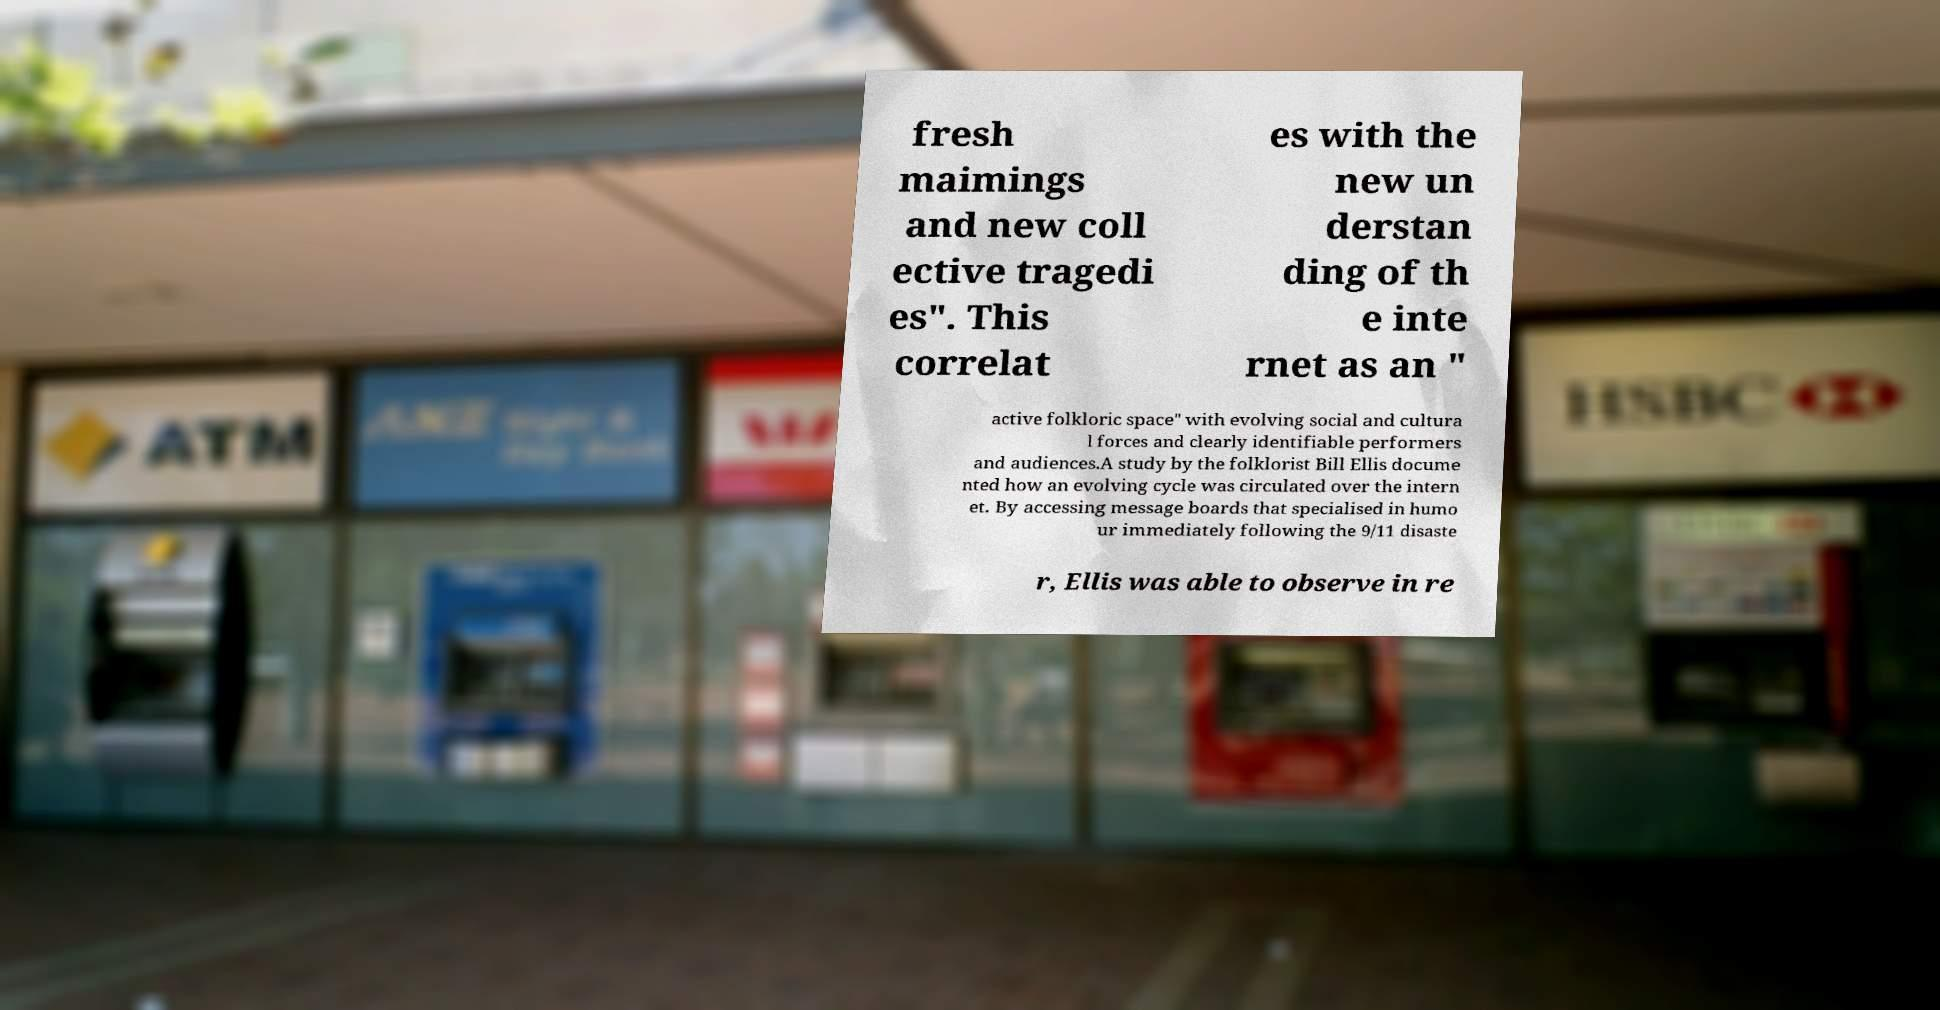What messages or text are displayed in this image? I need them in a readable, typed format. fresh maimings and new coll ective tragedi es". This correlat es with the new un derstan ding of th e inte rnet as an " active folkloric space" with evolving social and cultura l forces and clearly identifiable performers and audiences.A study by the folklorist Bill Ellis docume nted how an evolving cycle was circulated over the intern et. By accessing message boards that specialised in humo ur immediately following the 9/11 disaste r, Ellis was able to observe in re 